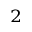Convert formula to latex. <formula><loc_0><loc_0><loc_500><loc_500>^ { 2 }</formula> 